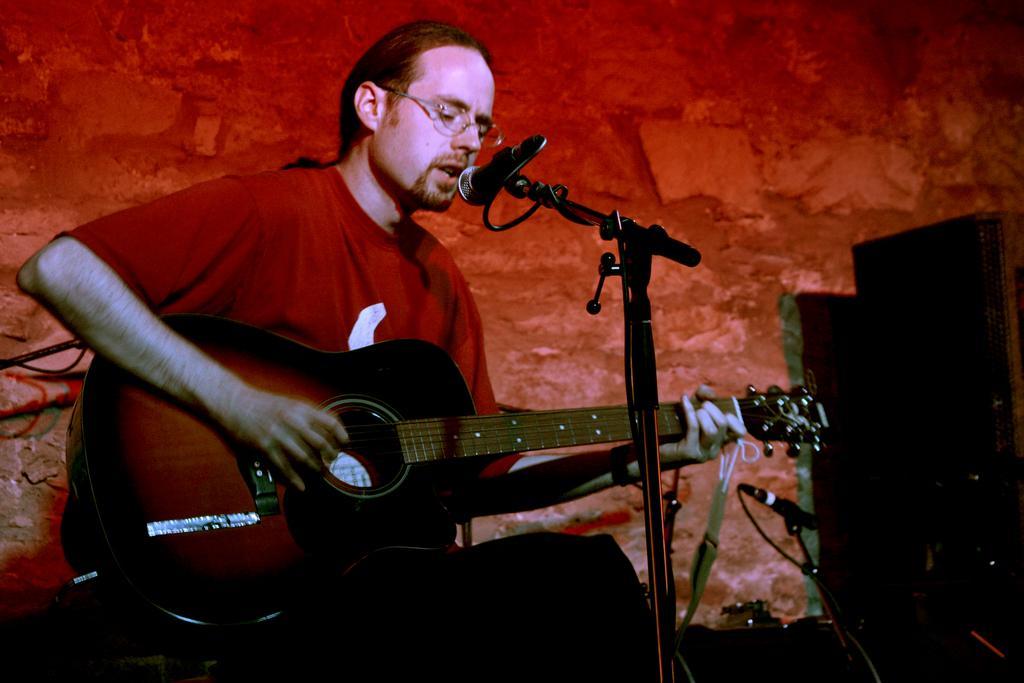Describe this image in one or two sentences. As we can see in the image there is a man holding guitar and singing on mic. 